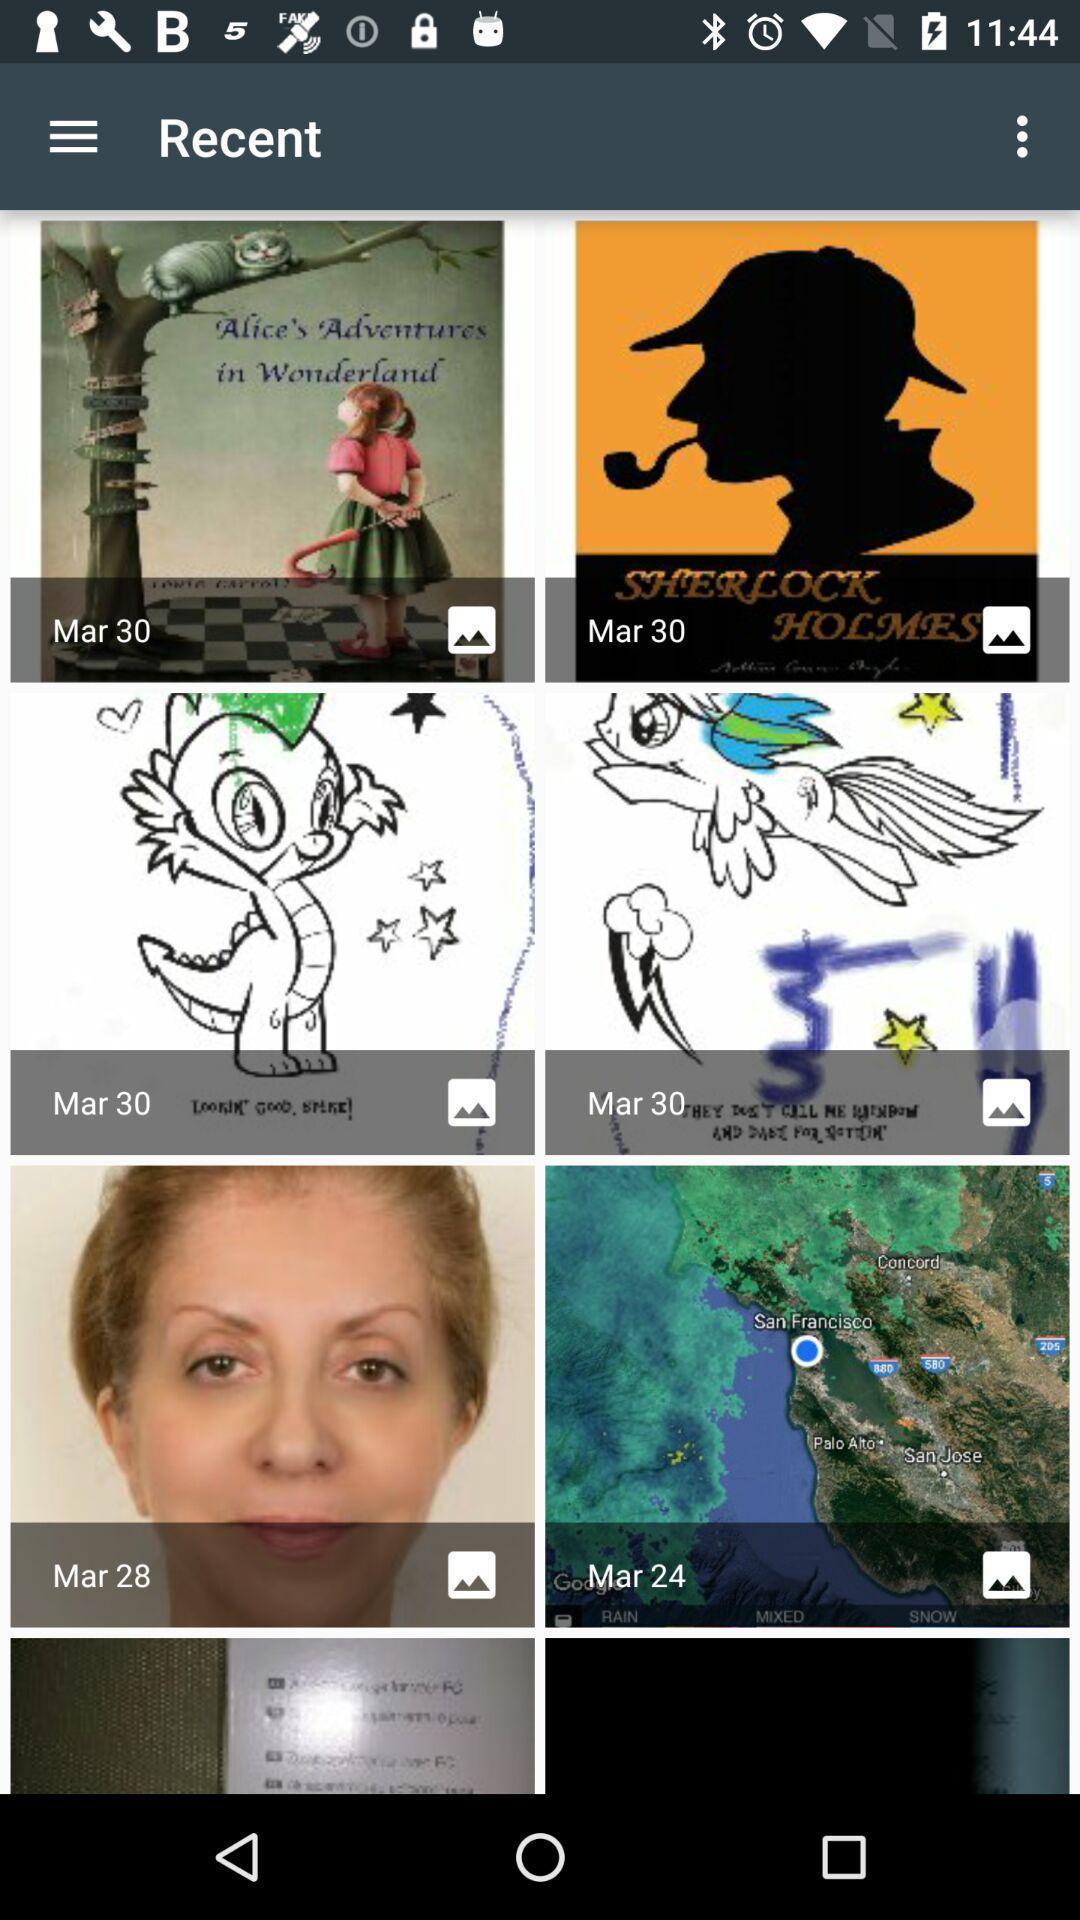Give me a summary of this screen capture. Page that displaying pdf files. 